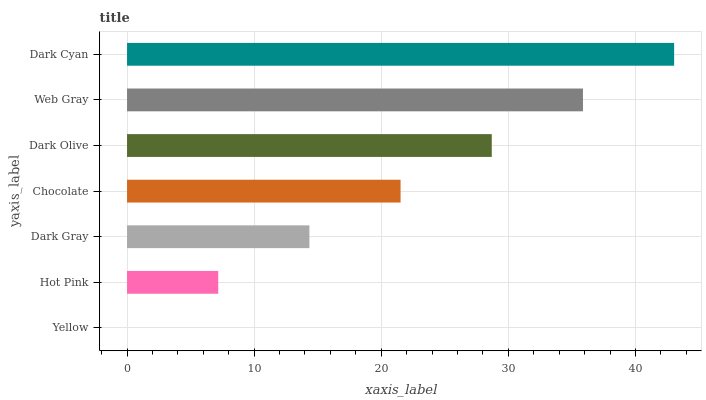Is Yellow the minimum?
Answer yes or no. Yes. Is Dark Cyan the maximum?
Answer yes or no. Yes. Is Hot Pink the minimum?
Answer yes or no. No. Is Hot Pink the maximum?
Answer yes or no. No. Is Hot Pink greater than Yellow?
Answer yes or no. Yes. Is Yellow less than Hot Pink?
Answer yes or no. Yes. Is Yellow greater than Hot Pink?
Answer yes or no. No. Is Hot Pink less than Yellow?
Answer yes or no. No. Is Chocolate the high median?
Answer yes or no. Yes. Is Chocolate the low median?
Answer yes or no. Yes. Is Hot Pink the high median?
Answer yes or no. No. Is Yellow the low median?
Answer yes or no. No. 